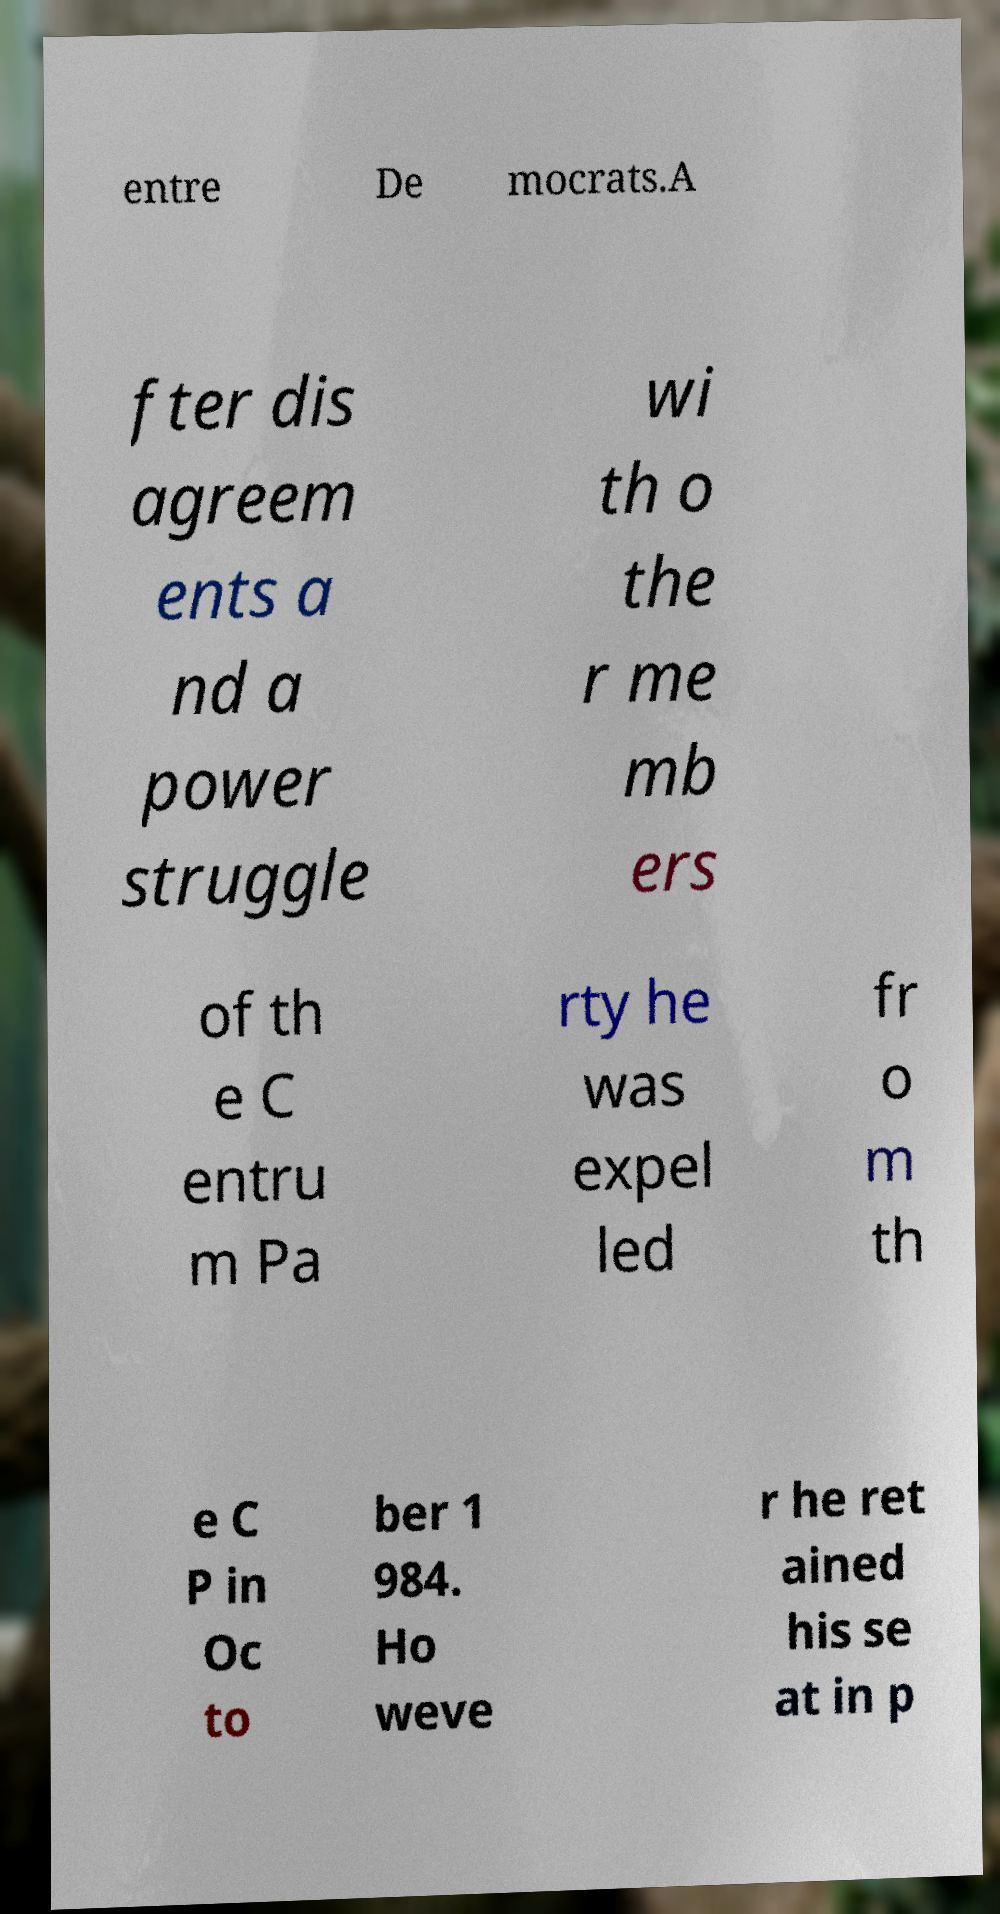What messages or text are displayed in this image? I need them in a readable, typed format. entre De mocrats.A fter dis agreem ents a nd a power struggle wi th o the r me mb ers of th e C entru m Pa rty he was expel led fr o m th e C P in Oc to ber 1 984. Ho weve r he ret ained his se at in p 